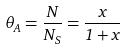<formula> <loc_0><loc_0><loc_500><loc_500>\theta _ { A } = \frac { N } { N _ { S } } = \frac { x } { 1 + x }</formula> 